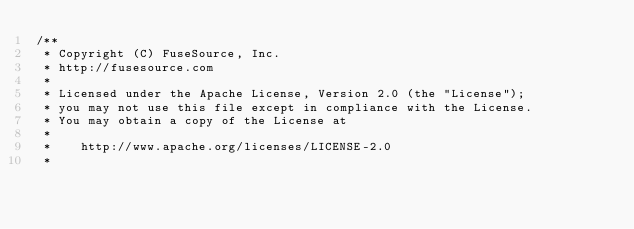<code> <loc_0><loc_0><loc_500><loc_500><_Java_>/**
 * Copyright (C) FuseSource, Inc.
 * http://fusesource.com
 *
 * Licensed under the Apache License, Version 2.0 (the "License");
 * you may not use this file except in compliance with the License.
 * You may obtain a copy of the License at
 *
 *    http://www.apache.org/licenses/LICENSE-2.0
 *</code> 